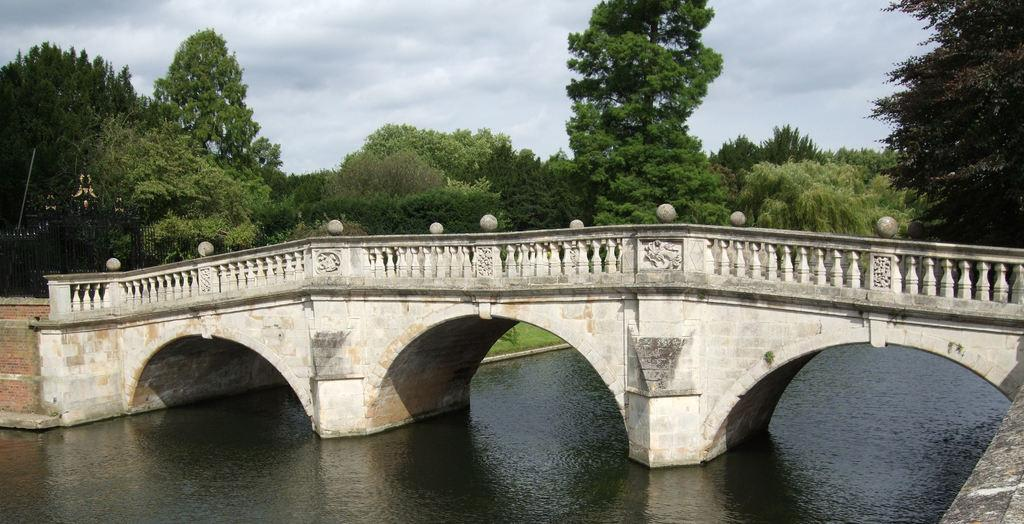What structure is featured in the image? There is a bridge in the image. What is the bridge spanning? The bridge is across a canal. What can be seen on the left side of the image? There are iron grilles on the left side of the image. What is visible in the background of the image? There are trees and the sky visible in the background of the image. What type of flag is flying on the bridge in the image? There is no flag visible on the bridge in the image. Can you spot an owl perched on the trees in the background? There is no owl present in the image; only trees and the sky are visible in the background. 